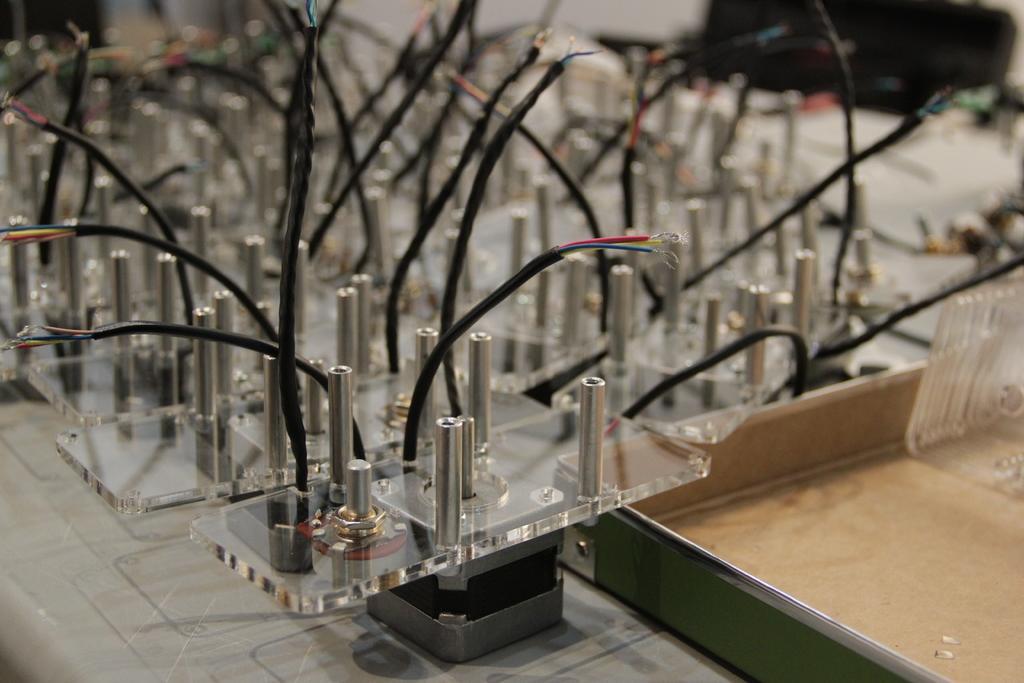Can you describe this image briefly? In the picture I can see few black wires and some other objects. 